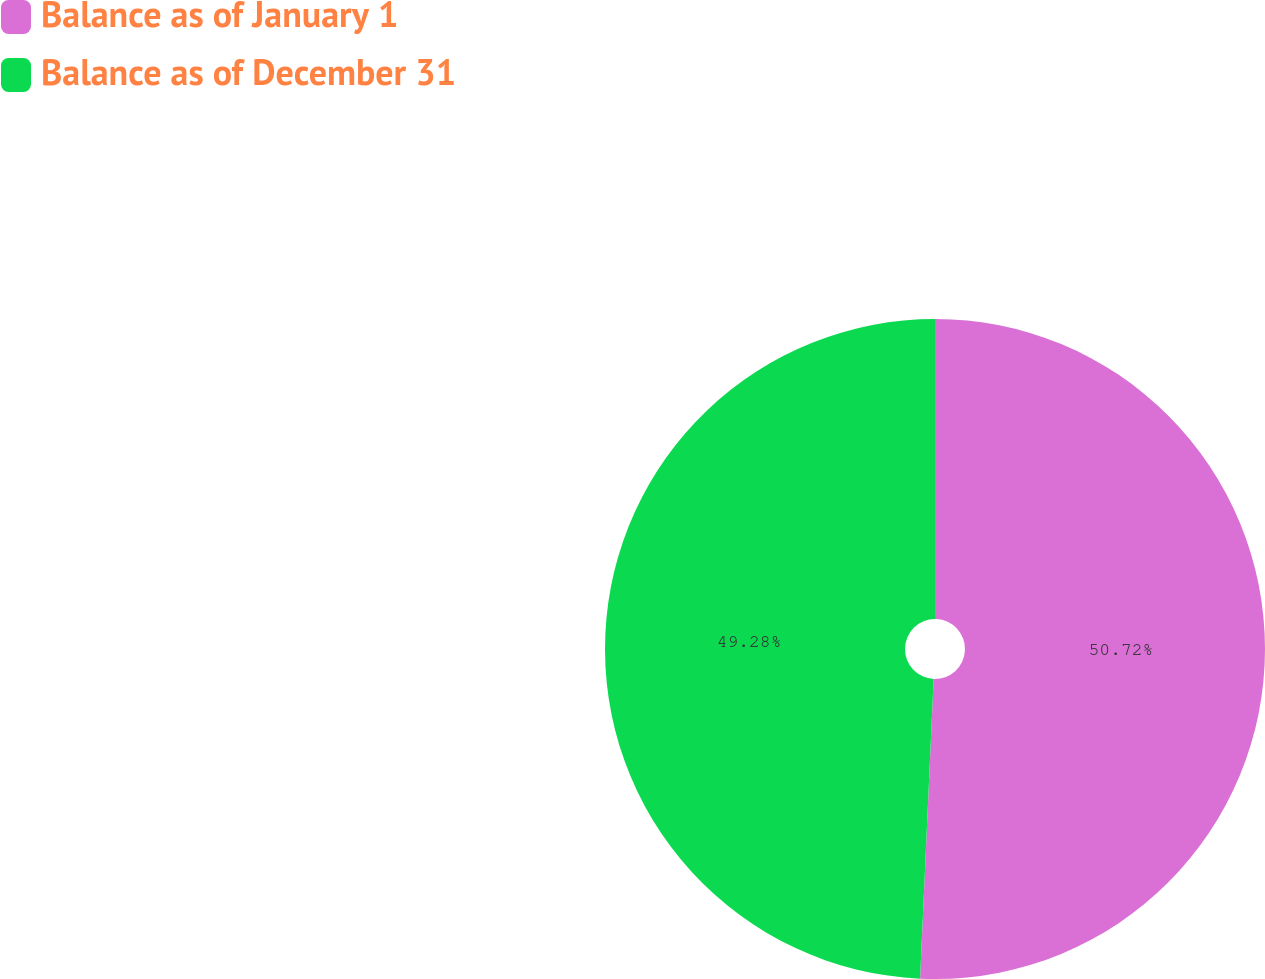Convert chart. <chart><loc_0><loc_0><loc_500><loc_500><pie_chart><fcel>Balance as of January 1<fcel>Balance as of December 31<nl><fcel>50.72%<fcel>49.28%<nl></chart> 